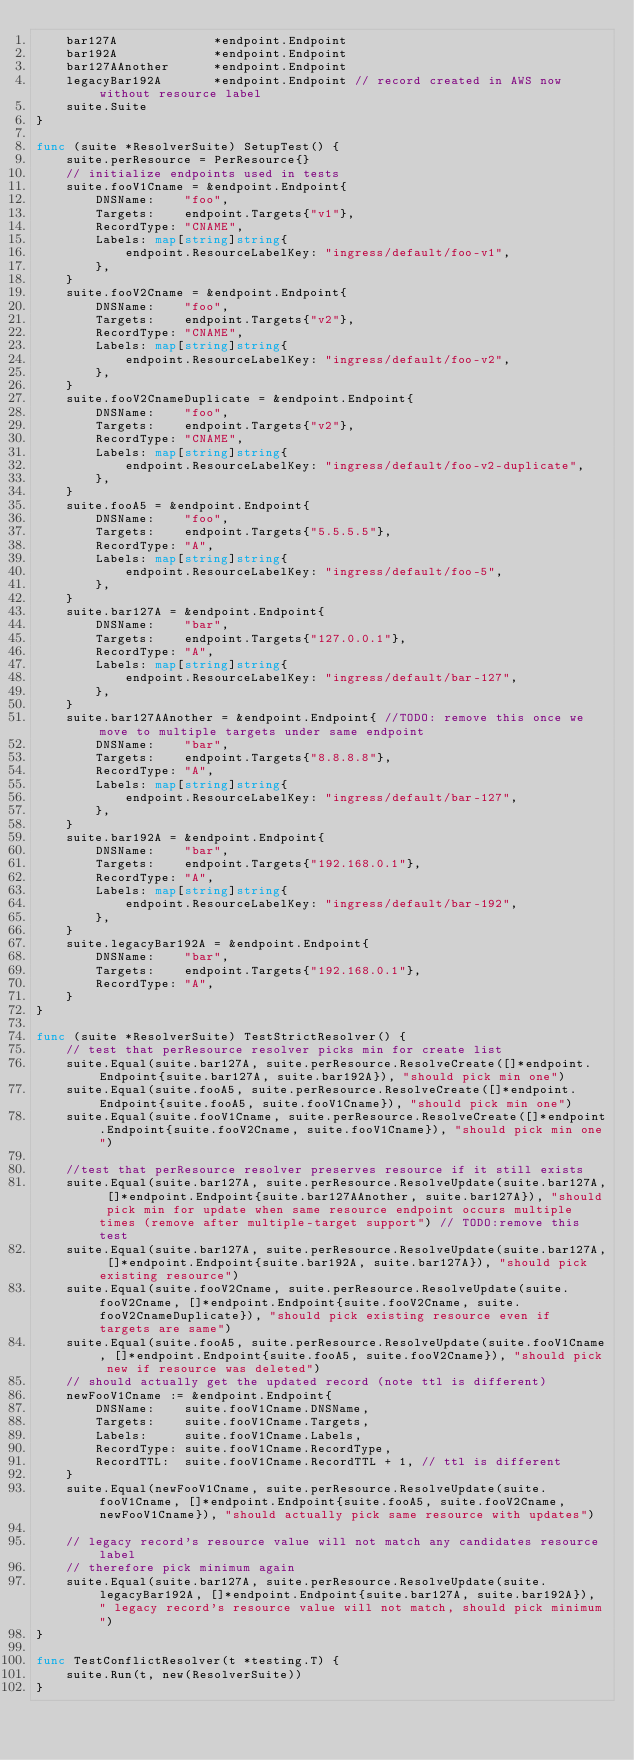Convert code to text. <code><loc_0><loc_0><loc_500><loc_500><_Go_>	bar127A             *endpoint.Endpoint
	bar192A             *endpoint.Endpoint
	bar127AAnother      *endpoint.Endpoint
	legacyBar192A       *endpoint.Endpoint // record created in AWS now without resource label
	suite.Suite
}

func (suite *ResolverSuite) SetupTest() {
	suite.perResource = PerResource{}
	// initialize endpoints used in tests
	suite.fooV1Cname = &endpoint.Endpoint{
		DNSName:    "foo",
		Targets:    endpoint.Targets{"v1"},
		RecordType: "CNAME",
		Labels: map[string]string{
			endpoint.ResourceLabelKey: "ingress/default/foo-v1",
		},
	}
	suite.fooV2Cname = &endpoint.Endpoint{
		DNSName:    "foo",
		Targets:    endpoint.Targets{"v2"},
		RecordType: "CNAME",
		Labels: map[string]string{
			endpoint.ResourceLabelKey: "ingress/default/foo-v2",
		},
	}
	suite.fooV2CnameDuplicate = &endpoint.Endpoint{
		DNSName:    "foo",
		Targets:    endpoint.Targets{"v2"},
		RecordType: "CNAME",
		Labels: map[string]string{
			endpoint.ResourceLabelKey: "ingress/default/foo-v2-duplicate",
		},
	}
	suite.fooA5 = &endpoint.Endpoint{
		DNSName:    "foo",
		Targets:    endpoint.Targets{"5.5.5.5"},
		RecordType: "A",
		Labels: map[string]string{
			endpoint.ResourceLabelKey: "ingress/default/foo-5",
		},
	}
	suite.bar127A = &endpoint.Endpoint{
		DNSName:    "bar",
		Targets:    endpoint.Targets{"127.0.0.1"},
		RecordType: "A",
		Labels: map[string]string{
			endpoint.ResourceLabelKey: "ingress/default/bar-127",
		},
	}
	suite.bar127AAnother = &endpoint.Endpoint{ //TODO: remove this once we move to multiple targets under same endpoint
		DNSName:    "bar",
		Targets:    endpoint.Targets{"8.8.8.8"},
		RecordType: "A",
		Labels: map[string]string{
			endpoint.ResourceLabelKey: "ingress/default/bar-127",
		},
	}
	suite.bar192A = &endpoint.Endpoint{
		DNSName:    "bar",
		Targets:    endpoint.Targets{"192.168.0.1"},
		RecordType: "A",
		Labels: map[string]string{
			endpoint.ResourceLabelKey: "ingress/default/bar-192",
		},
	}
	suite.legacyBar192A = &endpoint.Endpoint{
		DNSName:    "bar",
		Targets:    endpoint.Targets{"192.168.0.1"},
		RecordType: "A",
	}
}

func (suite *ResolverSuite) TestStrictResolver() {
	// test that perResource resolver picks min for create list
	suite.Equal(suite.bar127A, suite.perResource.ResolveCreate([]*endpoint.Endpoint{suite.bar127A, suite.bar192A}), "should pick min one")
	suite.Equal(suite.fooA5, suite.perResource.ResolveCreate([]*endpoint.Endpoint{suite.fooA5, suite.fooV1Cname}), "should pick min one")
	suite.Equal(suite.fooV1Cname, suite.perResource.ResolveCreate([]*endpoint.Endpoint{suite.fooV2Cname, suite.fooV1Cname}), "should pick min one")

	//test that perResource resolver preserves resource if it still exists
	suite.Equal(suite.bar127A, suite.perResource.ResolveUpdate(suite.bar127A, []*endpoint.Endpoint{suite.bar127AAnother, suite.bar127A}), "should pick min for update when same resource endpoint occurs multiple times (remove after multiple-target support") // TODO:remove this test
	suite.Equal(suite.bar127A, suite.perResource.ResolveUpdate(suite.bar127A, []*endpoint.Endpoint{suite.bar192A, suite.bar127A}), "should pick existing resource")
	suite.Equal(suite.fooV2Cname, suite.perResource.ResolveUpdate(suite.fooV2Cname, []*endpoint.Endpoint{suite.fooV2Cname, suite.fooV2CnameDuplicate}), "should pick existing resource even if targets are same")
	suite.Equal(suite.fooA5, suite.perResource.ResolveUpdate(suite.fooV1Cname, []*endpoint.Endpoint{suite.fooA5, suite.fooV2Cname}), "should pick new if resource was deleted")
	// should actually get the updated record (note ttl is different)
	newFooV1Cname := &endpoint.Endpoint{
		DNSName:    suite.fooV1Cname.DNSName,
		Targets:    suite.fooV1Cname.Targets,
		Labels:     suite.fooV1Cname.Labels,
		RecordType: suite.fooV1Cname.RecordType,
		RecordTTL:  suite.fooV1Cname.RecordTTL + 1, // ttl is different
	}
	suite.Equal(newFooV1Cname, suite.perResource.ResolveUpdate(suite.fooV1Cname, []*endpoint.Endpoint{suite.fooA5, suite.fooV2Cname, newFooV1Cname}), "should actually pick same resource with updates")

	// legacy record's resource value will not match any candidates resource label
	// therefore pick minimum again
	suite.Equal(suite.bar127A, suite.perResource.ResolveUpdate(suite.legacyBar192A, []*endpoint.Endpoint{suite.bar127A, suite.bar192A}), " legacy record's resource value will not match, should pick minimum")
}

func TestConflictResolver(t *testing.T) {
	suite.Run(t, new(ResolverSuite))
}
</code> 